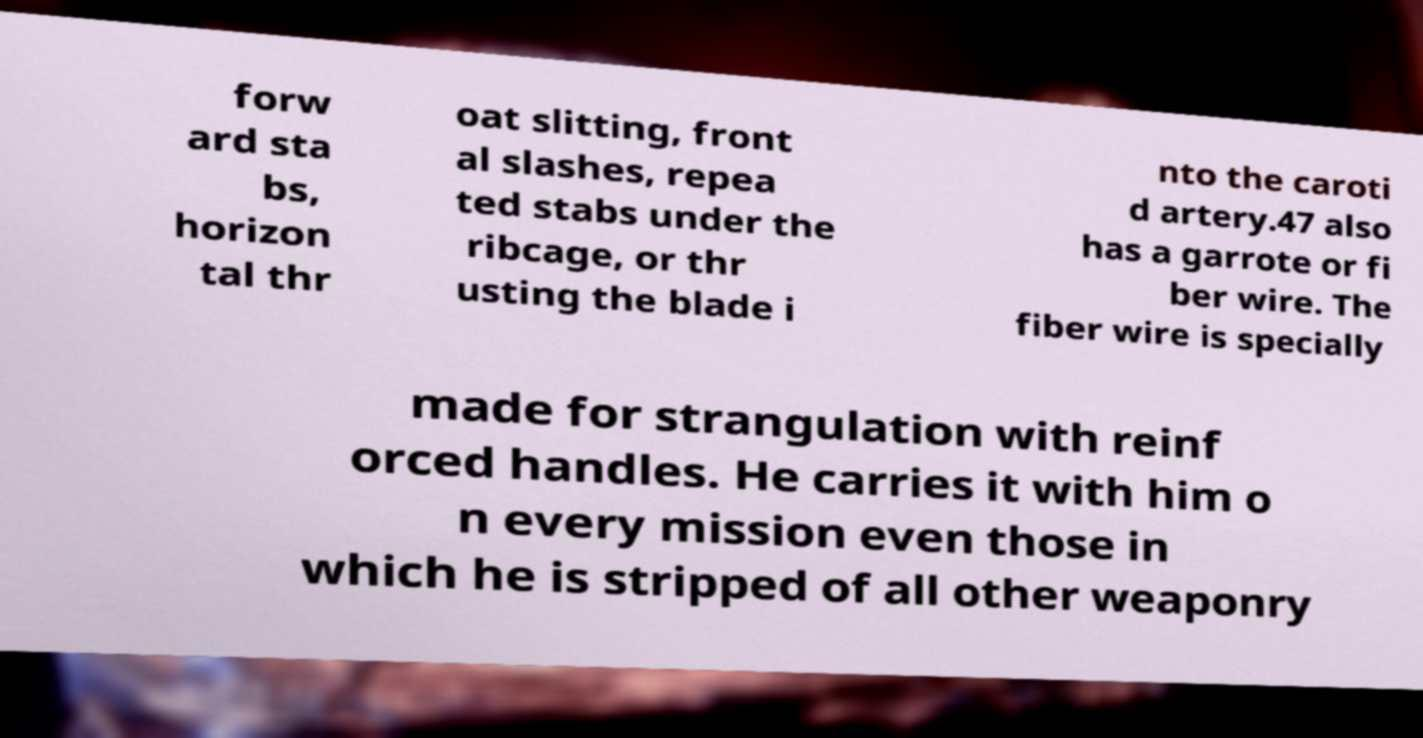Please identify and transcribe the text found in this image. forw ard sta bs, horizon tal thr oat slitting, front al slashes, repea ted stabs under the ribcage, or thr usting the blade i nto the caroti d artery.47 also has a garrote or fi ber wire. The fiber wire is specially made for strangulation with reinf orced handles. He carries it with him o n every mission even those in which he is stripped of all other weaponry 